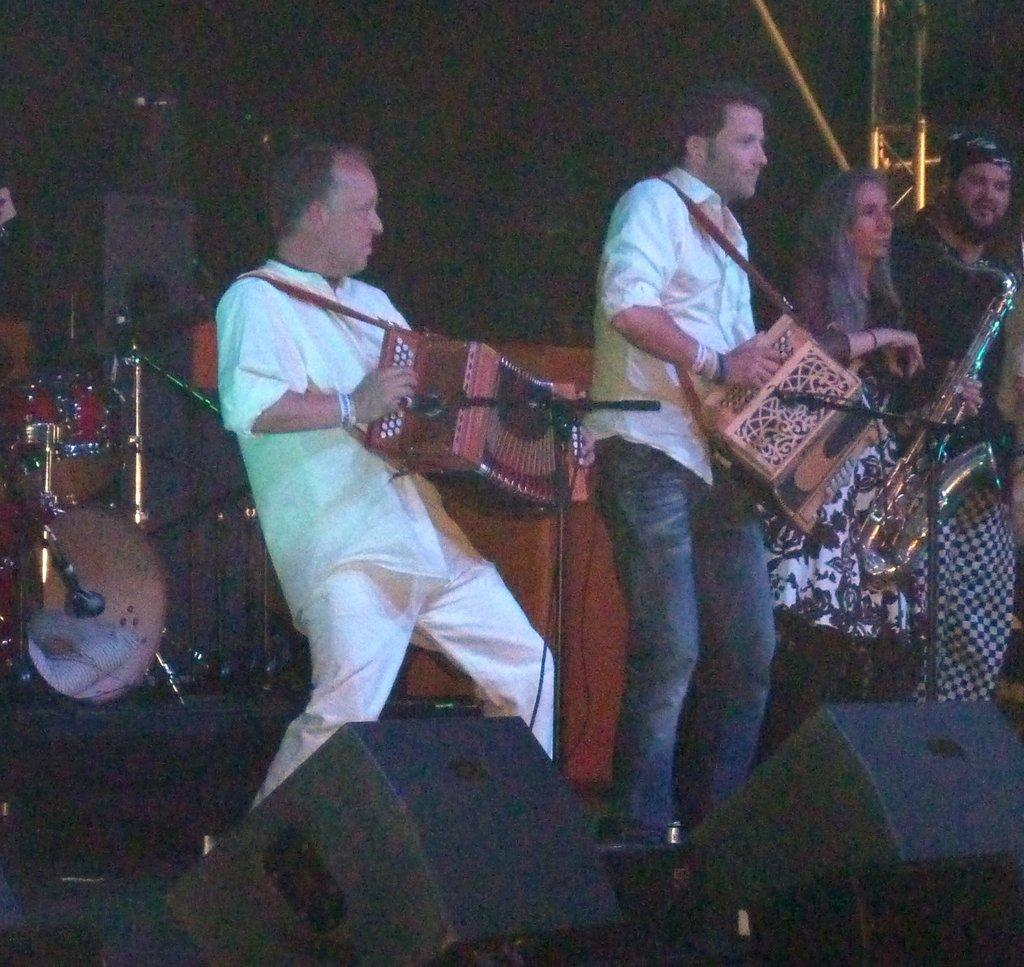What are the people in the center of the image doing? The people in the center of the image are standing and playing musical instruments. What can be seen in the background of the image? There is a band in the background of the image. What equipment is visible at the bottom of the image? Speakers are visible at the bottom of the image. What might be used for amplifying the sound of the instruments? There are microphones present. How does the coach help the band improve their performance in the image? There is no coach present in the image, so it is not possible to determine how they might help the band improve their performance. 